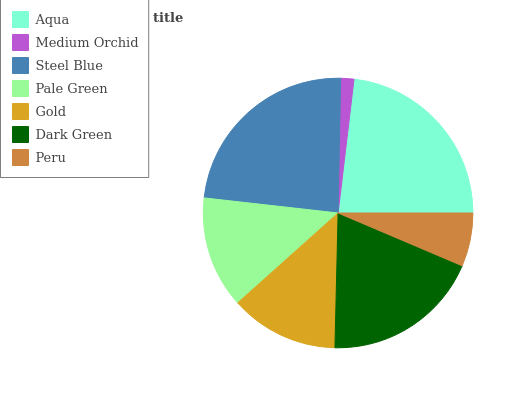Is Medium Orchid the minimum?
Answer yes or no. Yes. Is Steel Blue the maximum?
Answer yes or no. Yes. Is Steel Blue the minimum?
Answer yes or no. No. Is Medium Orchid the maximum?
Answer yes or no. No. Is Steel Blue greater than Medium Orchid?
Answer yes or no. Yes. Is Medium Orchid less than Steel Blue?
Answer yes or no. Yes. Is Medium Orchid greater than Steel Blue?
Answer yes or no. No. Is Steel Blue less than Medium Orchid?
Answer yes or no. No. Is Pale Green the high median?
Answer yes or no. Yes. Is Pale Green the low median?
Answer yes or no. Yes. Is Dark Green the high median?
Answer yes or no. No. Is Dark Green the low median?
Answer yes or no. No. 